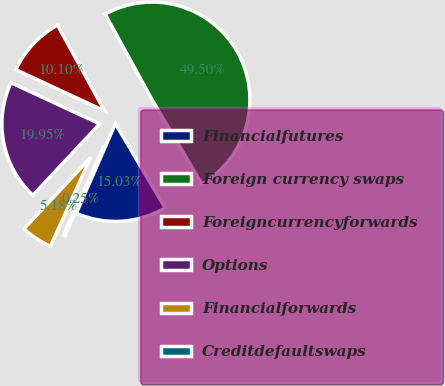Convert chart. <chart><loc_0><loc_0><loc_500><loc_500><pie_chart><fcel>Financialfutures<fcel>Foreign currency swaps<fcel>Foreigncurrencyforwards<fcel>Options<fcel>Financialforwards<fcel>Creditdefaultswaps<nl><fcel>15.03%<fcel>49.5%<fcel>10.1%<fcel>19.95%<fcel>5.18%<fcel>0.25%<nl></chart> 